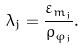Convert formula to latex. <formula><loc_0><loc_0><loc_500><loc_500>\lambda _ { j } = \frac { \varepsilon _ { m _ { j } } } { \rho _ { \varphi _ { j } } } .</formula> 